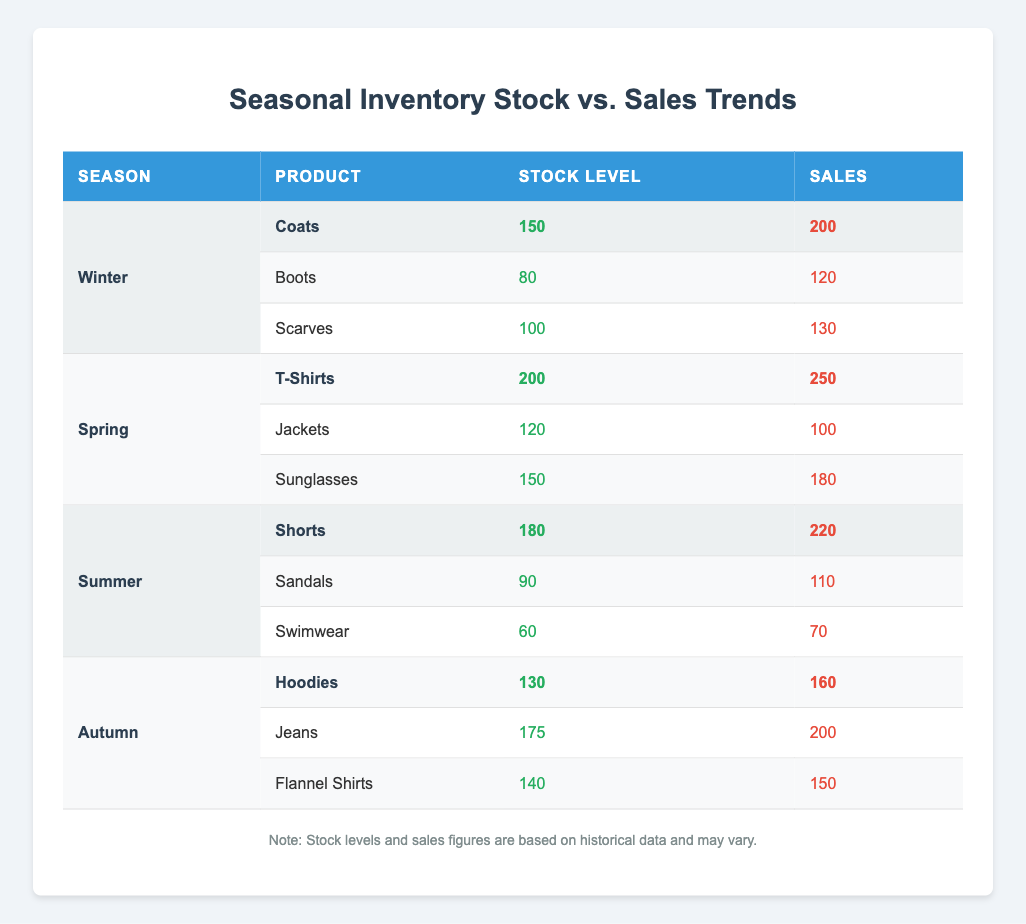What is the stock level for T-Shirts in Spring? From the table, we can see that the stock level for T-Shirts listed under Spring is 200.
Answer: 200 Which product had the highest sales in Winter? In the Winter section, looking at the sales numbers, Coats have the highest sales of 200, followed by Scarves with 130 and Boots with 120.
Answer: Coats What is the total stock level for products in Autumn? For Autumn, the stock levels are Hoodies (130), Jeans (175), and Flannel Shirts (140). Adding these together gives us: 130 + 175 + 140 = 445.
Answer: 445 Did Swimwear sell above its stock level in Summer? The sales figure for Swimwear is 70, and its stock level is 60. Since sales (70) exceeded stock (60), the statement is true.
Answer: Yes What is the average stock level across all seasons? To find the average, we first calculate total stock across all seasons: Winter (150+80+100), Spring (200+120+150), Summer (180+90+60), Autumn (130+175+140). Summing these gives us 150 + 80 + 100 + 200 + 120 + 150 + 180 + 90 + 60 + 130 + 175 + 140 = 1,405. Since there are 12 products, the average is 1,405 / 12 ≈ 117.08.
Answer: 117.08 Which season had the lowest total sales? Analyzing the sales figures, we have Winter (200 + 120 + 130), Spring (250 + 100 + 180), Summer (220 + 110 + 70), and Autumn (160 + 200 + 150). Calculating totals gives: Winter 450, Spring 530, Summer 400, Autumn 510. Therefore, Summer has the lowest total sales at 400.
Answer: Summer 